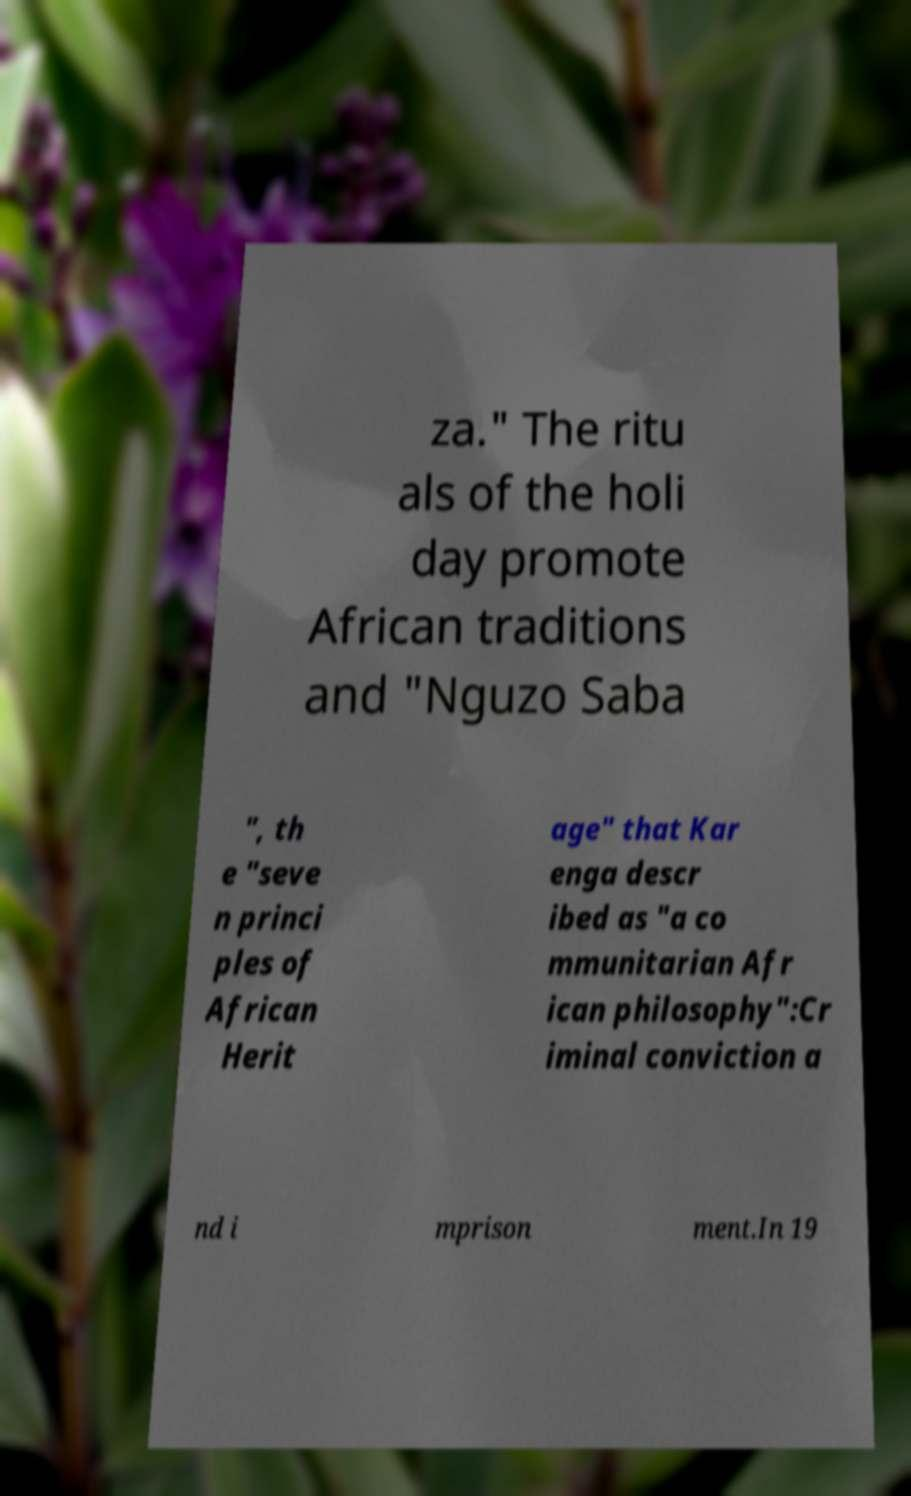There's text embedded in this image that I need extracted. Can you transcribe it verbatim? za." The ritu als of the holi day promote African traditions and "Nguzo Saba ", th e "seve n princi ples of African Herit age" that Kar enga descr ibed as "a co mmunitarian Afr ican philosophy":Cr iminal conviction a nd i mprison ment.In 19 